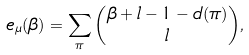Convert formula to latex. <formula><loc_0><loc_0><loc_500><loc_500>e _ { \mu } ( \beta ) = \sum _ { \pi } \binom { \beta + l - 1 - d ( \pi ) } { l } ,</formula> 